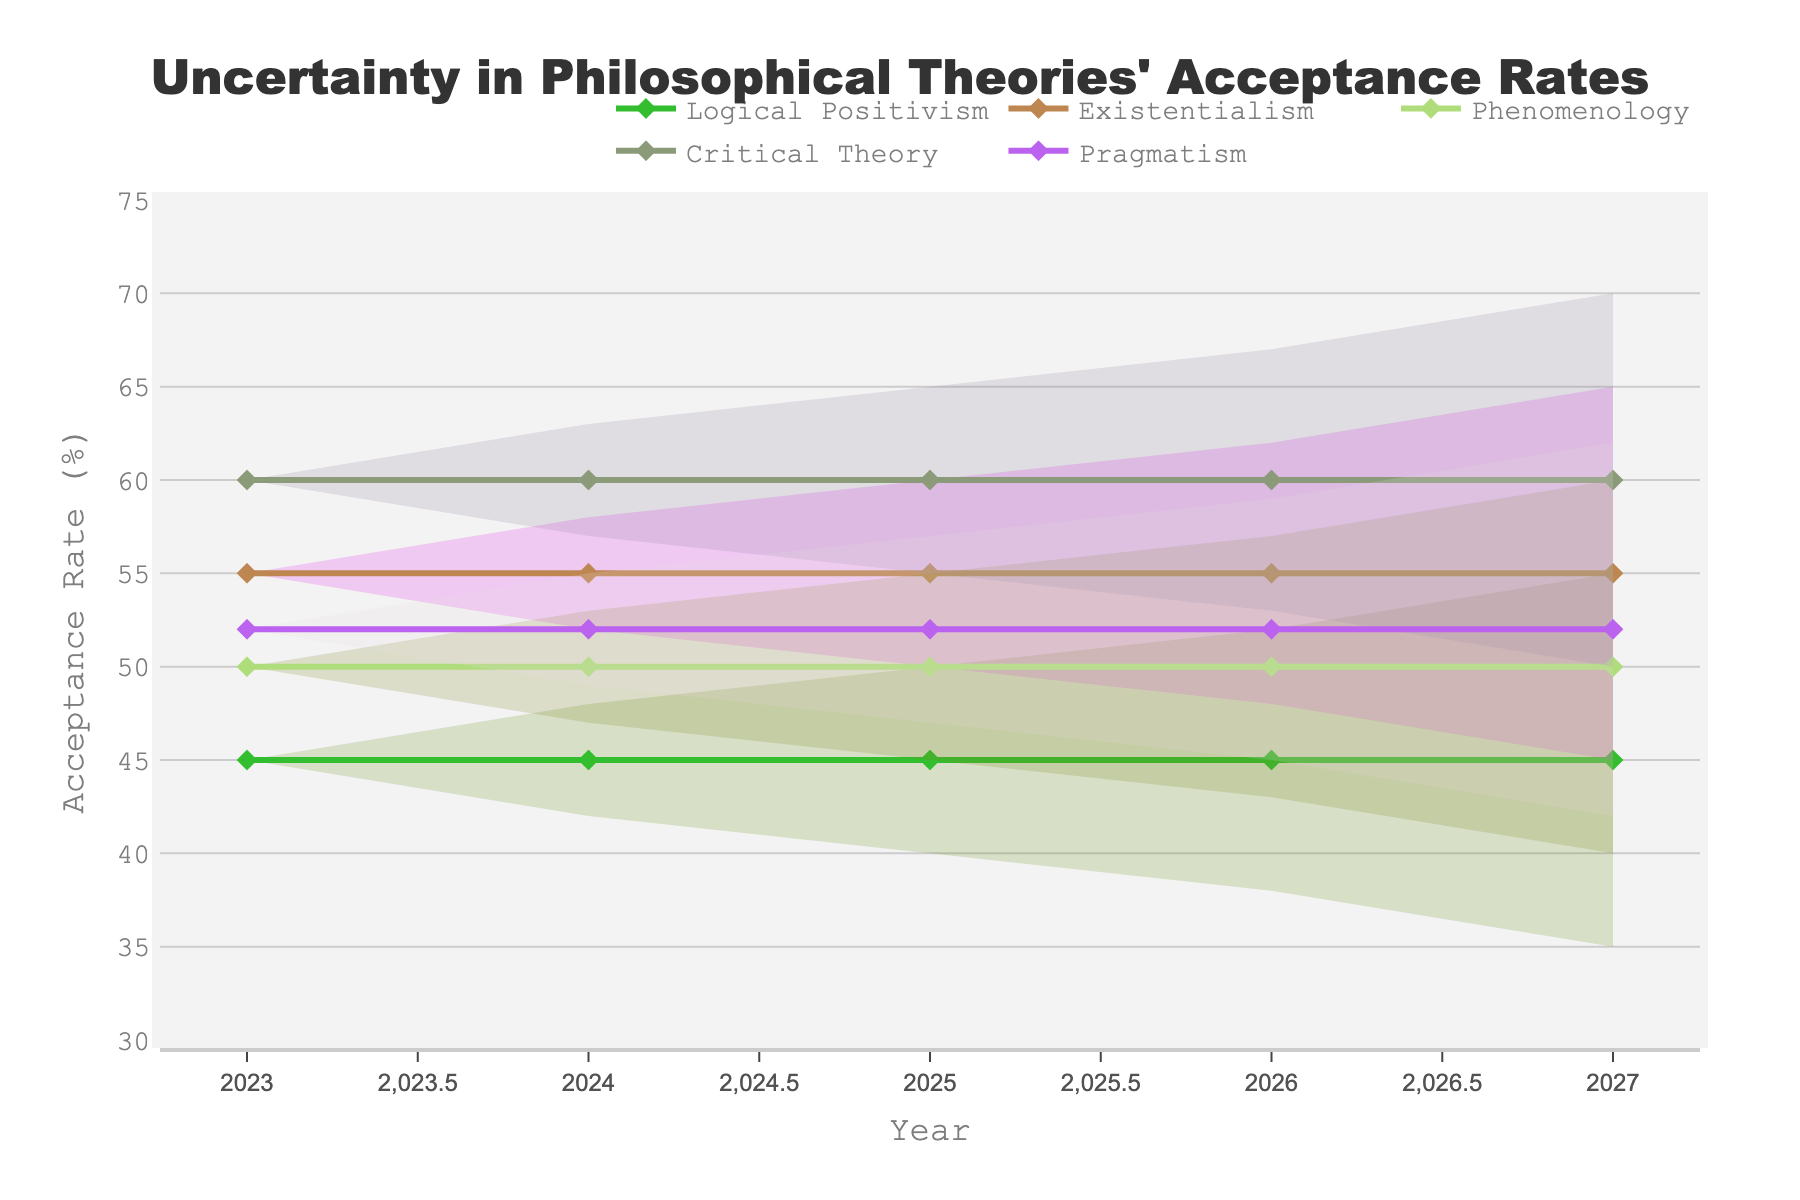What is the title of the Figure? Look at the top of the figure where the main heading is located.
Answer: Uncertainty in Philosophical Theories' Acceptance Rates How many different philosophical theories are represented in the Figure? Identify the number of distinct theory names in the legend or axis labels. Count them.
Answer: 5 What is the acceptance rate range for Critical Theory in 2027? Locate the range for Critical Theory in the Year 2027 in the graph and refer to the upper and lower boundaries of the shaded area.
Answer: 50-70 Between which years do you observe the smallest uncertainty range for Logical Positivism? Compare the width of the shaded areas for Logical Positivism across all years to find where it is smallest.
Answer: 2023 Which theory shows the highest acceptance rate in 2023? Examine the points and lines in the year 2023 and identify the one with the highest value.
Answer: Critical Theory Which theory shows the widest range of acceptance rates in 2027? Look at all the theories in 2027 and compare the width of the shaded range for each.
Answer: Critical Theory Has the acceptance rate for Pragmatism increased or decreased from 2023 to 2027? Look at the central line for Pragmatism and note the value in 2023 then 2027 to see if it has increased or decreased.
Answer: Decreased Is the average acceptance rate for Logical Positivism in 2025 closest to its lower bound, upper bound, or midpoint in 2026? Calculate the central value of Logical Positivism in 2025 and 2026, and compare them. Logical Positivism in 2025 has an average of (40+50)/2 = 45. In 2026, the average is (38+52)/2 = 45. Compare these averages to the bounds.
Answer: Midpoint Which year shows the highest overall uncertainty range among all theories? Measure the width of the uncertainty regions (shaded areas) for all theories across all years, then find the year with the largest total range.
Answer: 2027 Compare the acceptance rate ranges for Existentialism and Phenomenology in 2024. Which one has a broader range? Calculate the range (upper bound - lower bound) for Existentialism and Phenomenology in 2024, and compare. For Existentialism, the range is (58-52)=6, for Phenomenology, the range is (53-47)=6. Compare these results.
Answer: Equal 